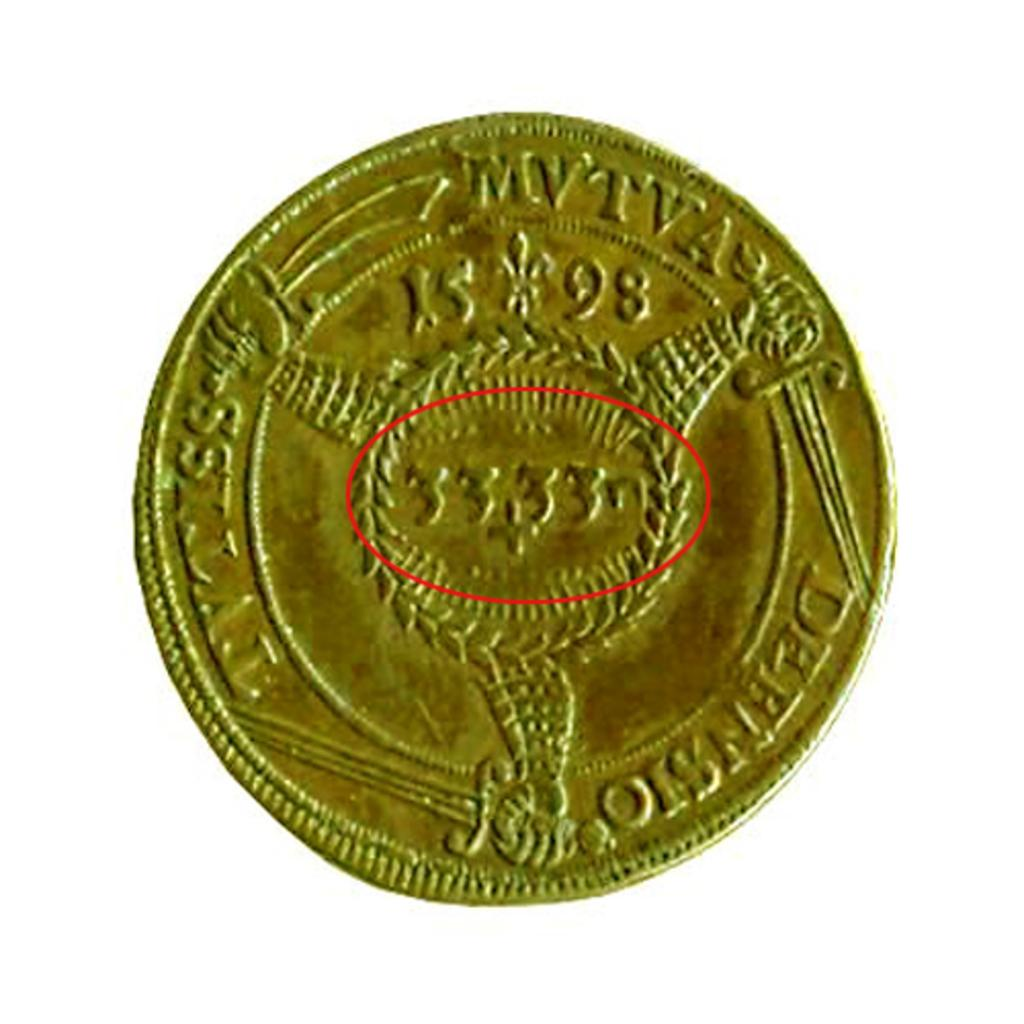Provide a one-sentence caption for the provided image. A gold coin has a red circle on it that notates the number 3333. 